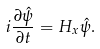<formula> <loc_0><loc_0><loc_500><loc_500>i \frac { \partial \hat { \psi } } { \partial t } = H _ { x } \hat { \psi } .</formula> 